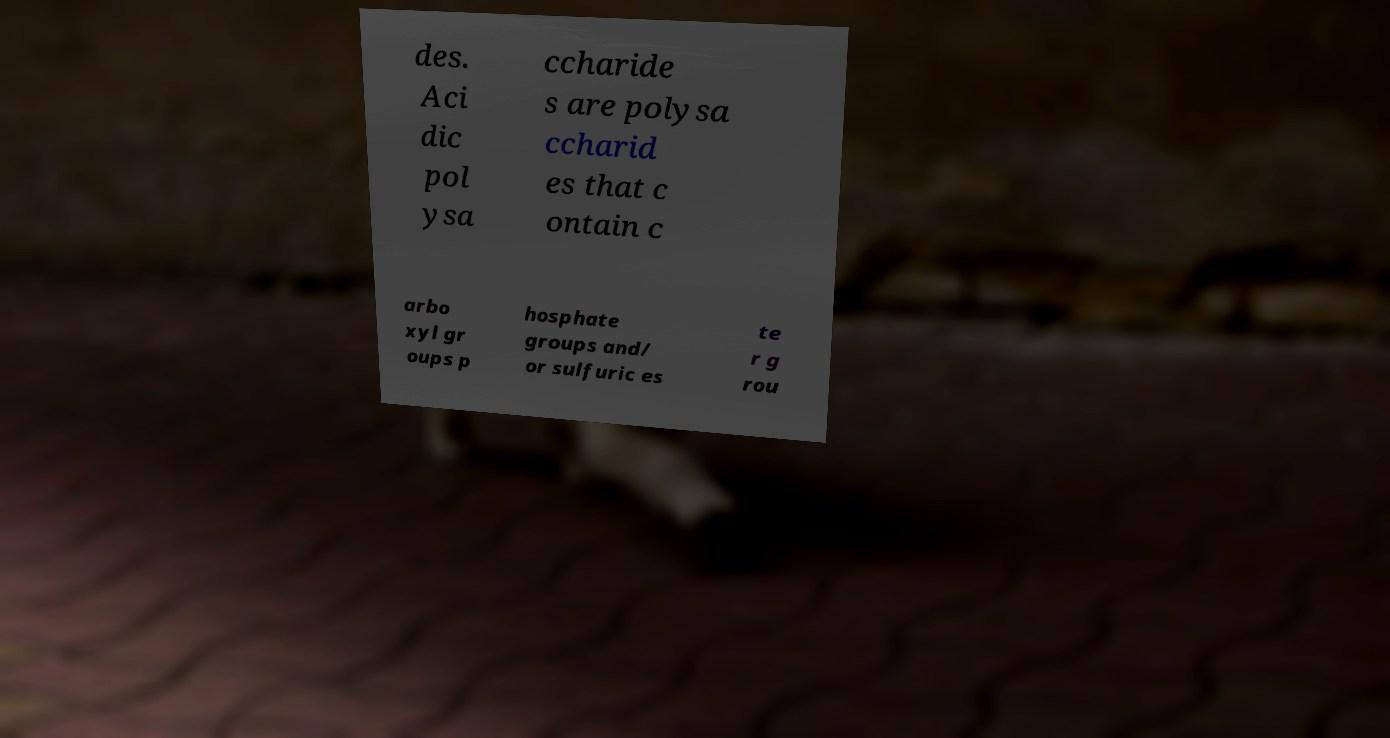Could you assist in decoding the text presented in this image and type it out clearly? des. Aci dic pol ysa ccharide s are polysa ccharid es that c ontain c arbo xyl gr oups p hosphate groups and/ or sulfuric es te r g rou 